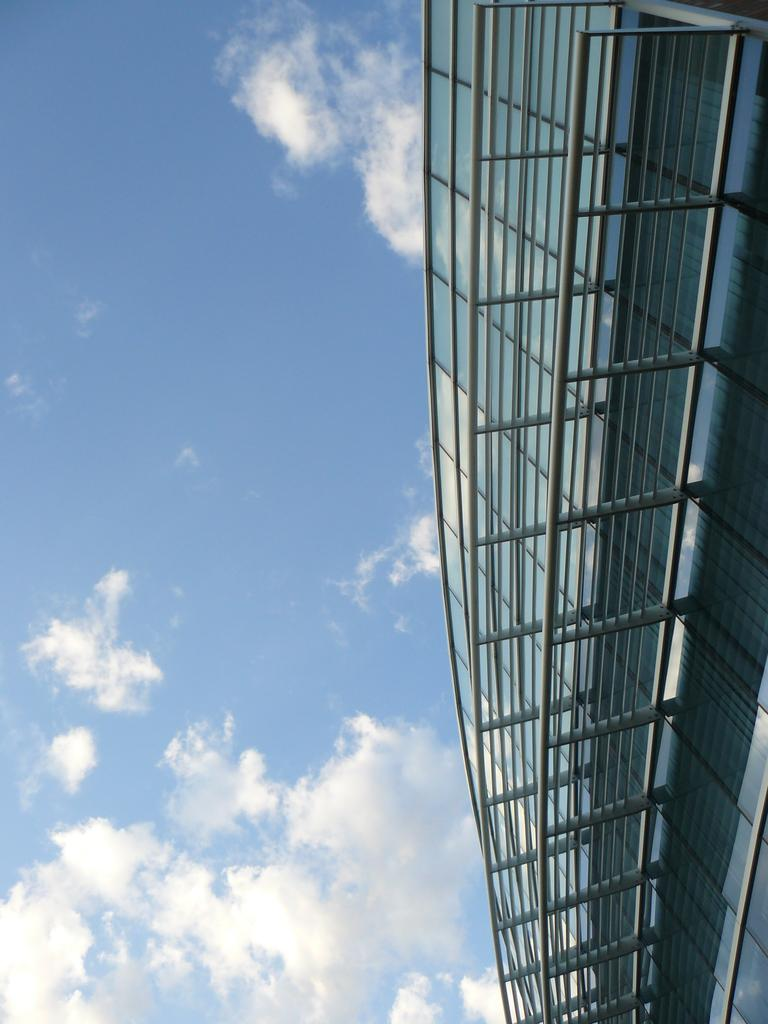What structure is located on the left side of the image? There is a building with a fence on the left side of the image. What is visible on the left side of the image besides the building? The sky is visible on the left side of the image. What can be seen in the sky on the left side of the image? There are clouds in the sky on the left side of the image. What type of glue is being used to hold the clouds together in the image? There is no glue present in the image; the clouds are naturally occurring in the sky. 